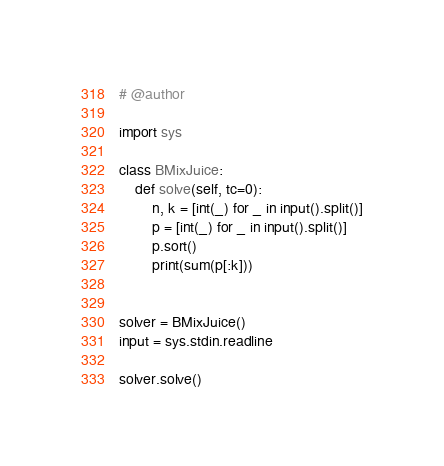Convert code to text. <code><loc_0><loc_0><loc_500><loc_500><_Python_># @author 

import sys

class BMixJuice:
    def solve(self, tc=0):
        n, k = [int(_) for _ in input().split()]
        p = [int(_) for _ in input().split()]
        p.sort()
        print(sum(p[:k]))


solver = BMixJuice()
input = sys.stdin.readline

solver.solve()
</code> 